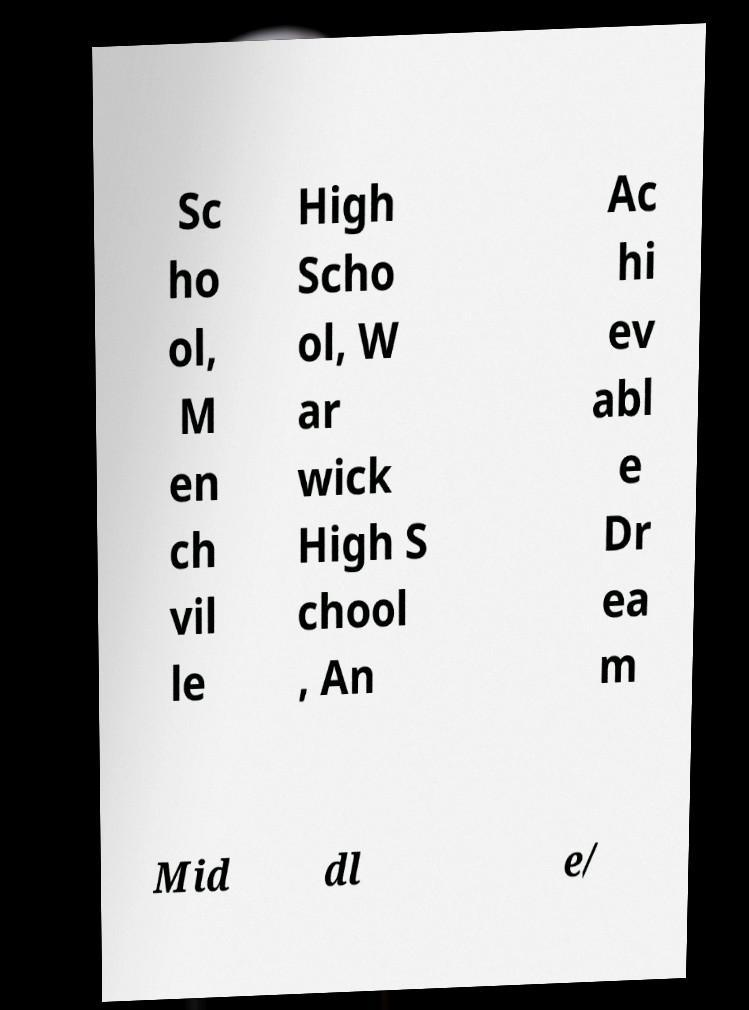Can you read and provide the text displayed in the image?This photo seems to have some interesting text. Can you extract and type it out for me? Sc ho ol, M en ch vil le High Scho ol, W ar wick High S chool , An Ac hi ev abl e Dr ea m Mid dl e/ 